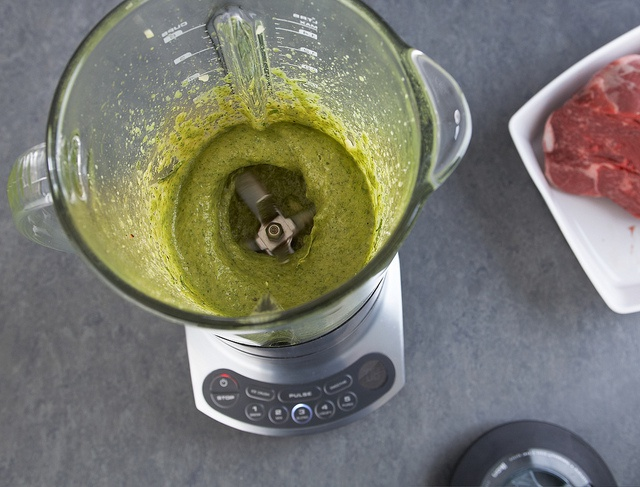Describe the objects in this image and their specific colors. I can see various objects in this image with different colors. 